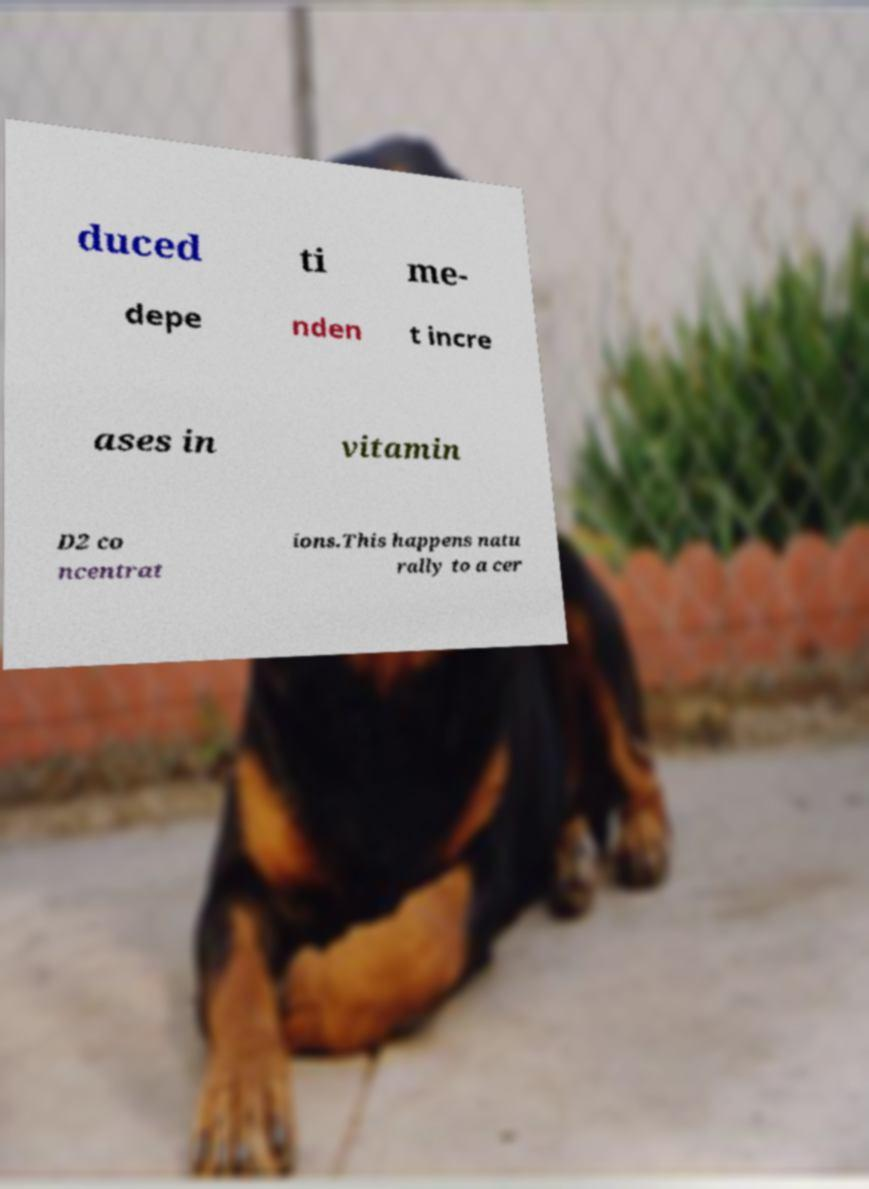Please identify and transcribe the text found in this image. duced ti me- depe nden t incre ases in vitamin D2 co ncentrat ions.This happens natu rally to a cer 